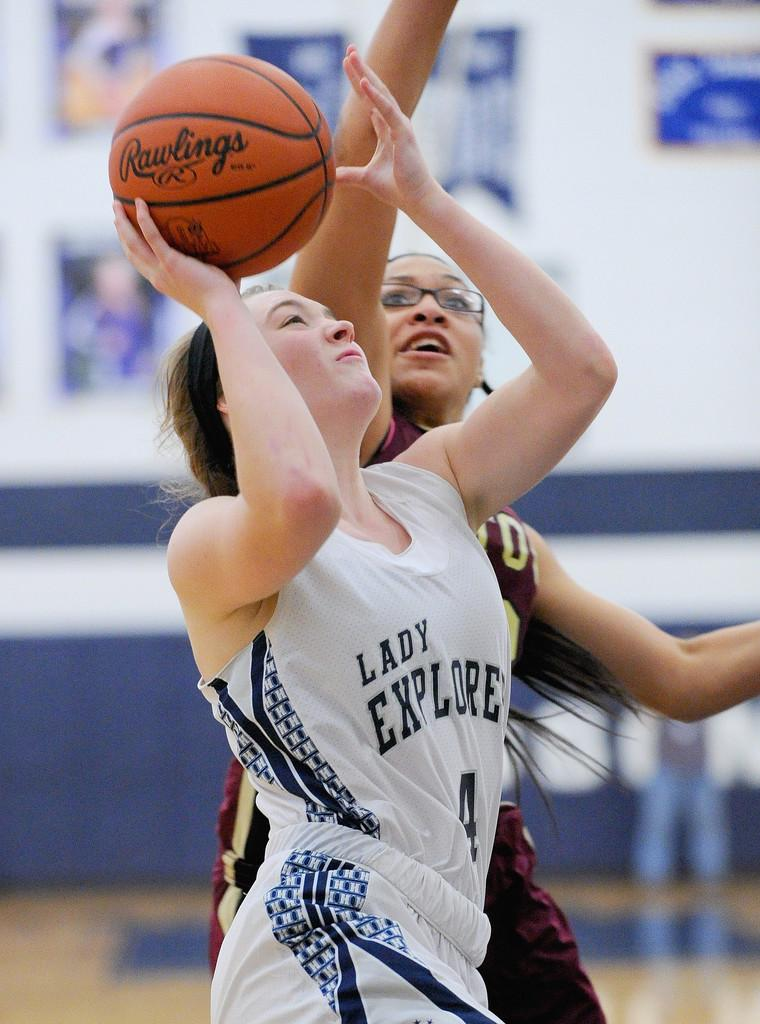<image>
Give a short and clear explanation of the subsequent image. a couple players one with the name Lady Explore on her jersey 